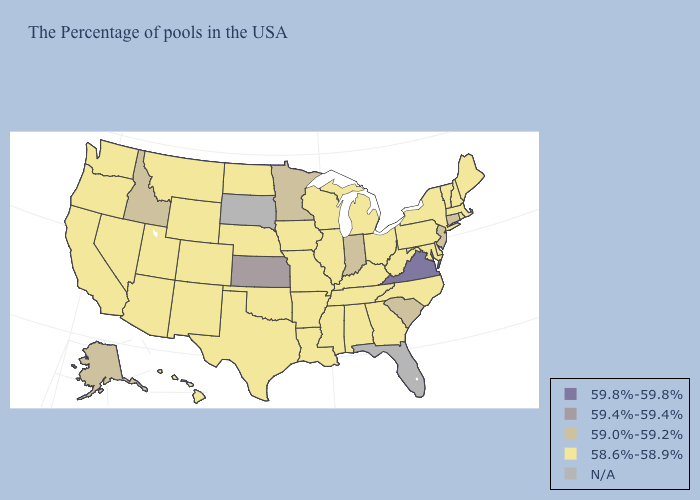What is the value of California?
Short answer required. 58.6%-58.9%. Name the states that have a value in the range N/A?
Keep it brief. Florida, South Dakota. Which states have the lowest value in the USA?
Concise answer only. Maine, Massachusetts, Rhode Island, New Hampshire, Vermont, New York, Delaware, Maryland, Pennsylvania, North Carolina, West Virginia, Ohio, Georgia, Michigan, Kentucky, Alabama, Tennessee, Wisconsin, Illinois, Mississippi, Louisiana, Missouri, Arkansas, Iowa, Nebraska, Oklahoma, Texas, North Dakota, Wyoming, Colorado, New Mexico, Utah, Montana, Arizona, Nevada, California, Washington, Oregon, Hawaii. Does the first symbol in the legend represent the smallest category?
Keep it brief. No. Name the states that have a value in the range 59.0%-59.2%?
Keep it brief. Connecticut, New Jersey, South Carolina, Indiana, Minnesota, Idaho, Alaska. Which states have the lowest value in the USA?
Short answer required. Maine, Massachusetts, Rhode Island, New Hampshire, Vermont, New York, Delaware, Maryland, Pennsylvania, North Carolina, West Virginia, Ohio, Georgia, Michigan, Kentucky, Alabama, Tennessee, Wisconsin, Illinois, Mississippi, Louisiana, Missouri, Arkansas, Iowa, Nebraska, Oklahoma, Texas, North Dakota, Wyoming, Colorado, New Mexico, Utah, Montana, Arizona, Nevada, California, Washington, Oregon, Hawaii. What is the highest value in states that border West Virginia?
Write a very short answer. 59.8%-59.8%. Among the states that border Kentucky , which have the lowest value?
Concise answer only. West Virginia, Ohio, Tennessee, Illinois, Missouri. Among the states that border Arizona , which have the lowest value?
Quick response, please. Colorado, New Mexico, Utah, Nevada, California. What is the highest value in states that border Kansas?
Answer briefly. 58.6%-58.9%. What is the highest value in states that border California?
Quick response, please. 58.6%-58.9%. Name the states that have a value in the range 59.4%-59.4%?
Short answer required. Kansas. 